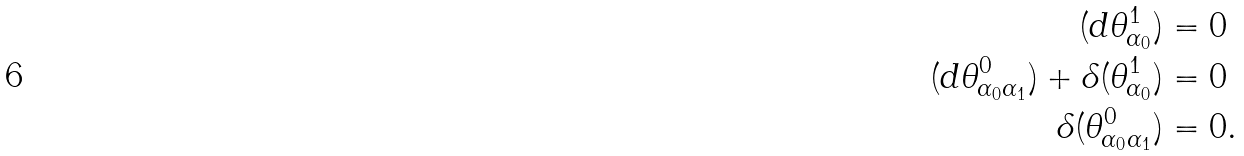<formula> <loc_0><loc_0><loc_500><loc_500>( d \theta ^ { 1 } _ { \alpha _ { 0 } } ) & = 0 \\ ( d \theta ^ { 0 } _ { \alpha _ { 0 } \alpha _ { 1 } } ) + \delta ( \theta _ { \alpha _ { 0 } } ^ { 1 } ) & = 0 \\ \delta ( \theta ^ { 0 } _ { \alpha _ { 0 } \alpha _ { 1 } } ) & = 0 .</formula> 